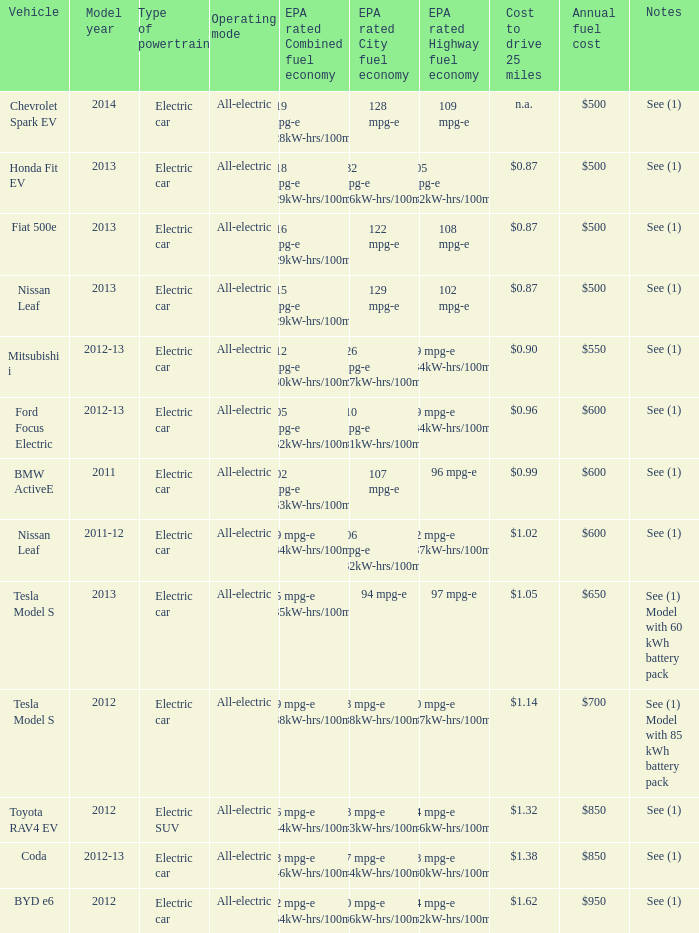What vehicle has an epa highway fuel economy of 109 mpg-e? Chevrolet Spark EV. 